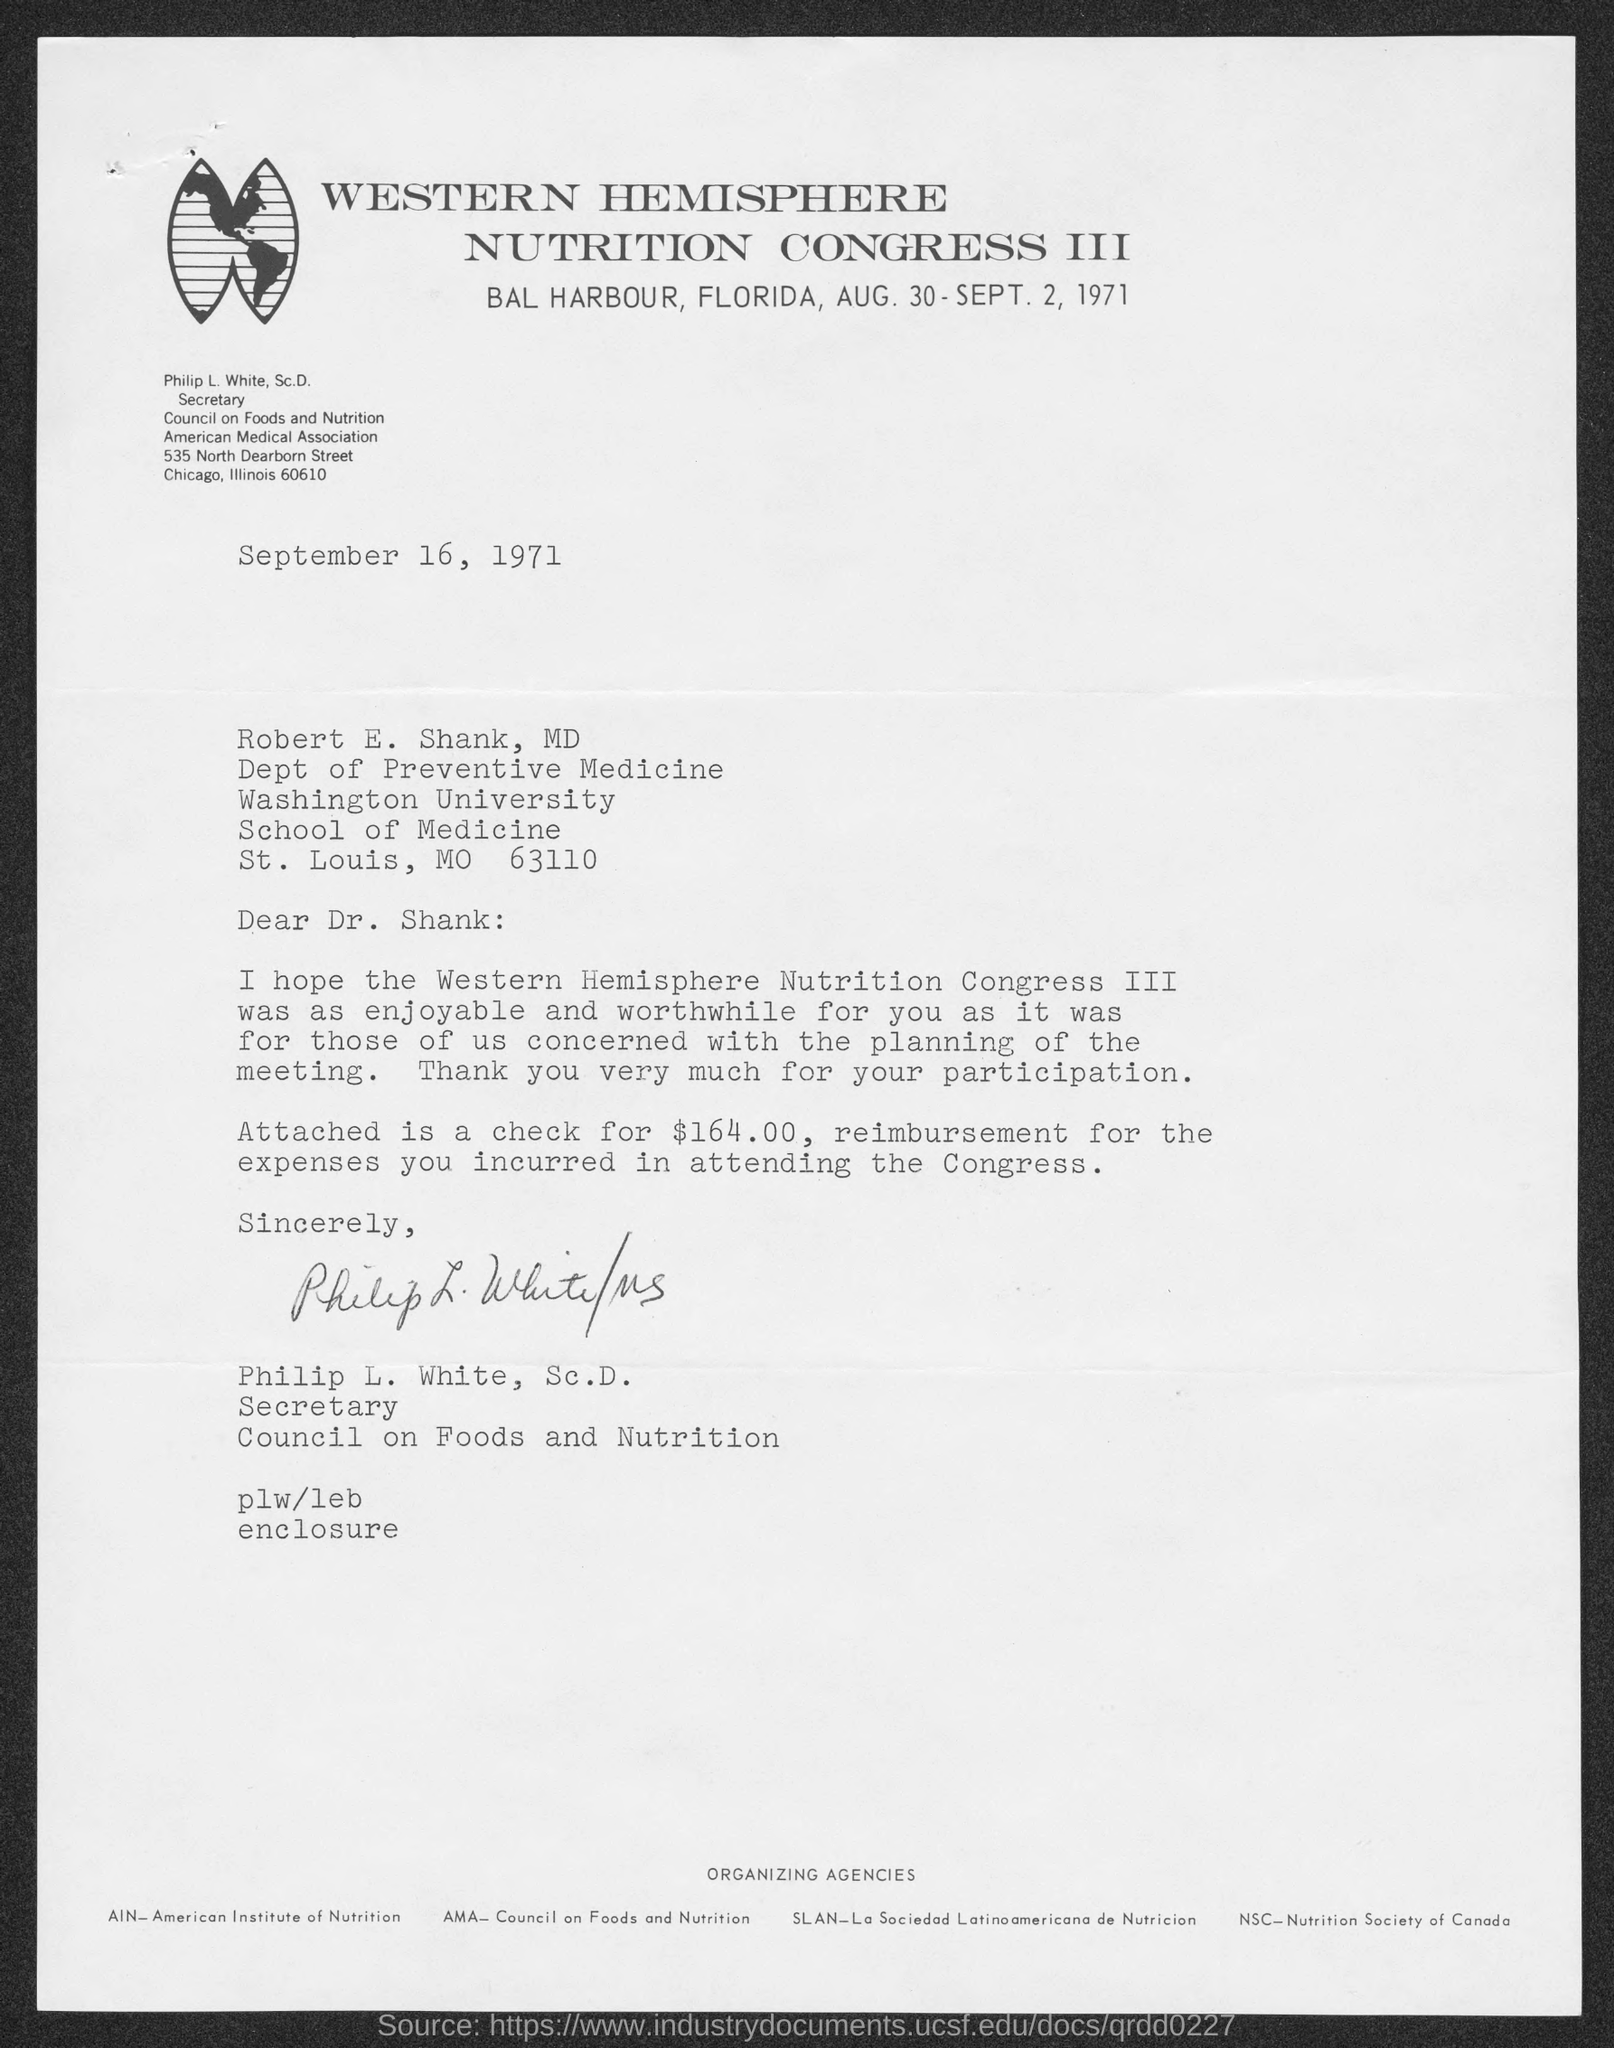Highlight a few significant elements in this photo. The document is dated September 16, 1971. The Western Hemisphere Nutrition Congress III will be held. The location of the upcoming congress has been confirmed to be Bal Harbour, Florida. American Institute of Nutrition is an organization that specializes in the study of nutrition. The amount of the check for reimbursement is $164.00. 